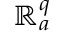<formula> <loc_0><loc_0><loc_500><loc_500>\mathbb { R } _ { a } ^ { q }</formula> 